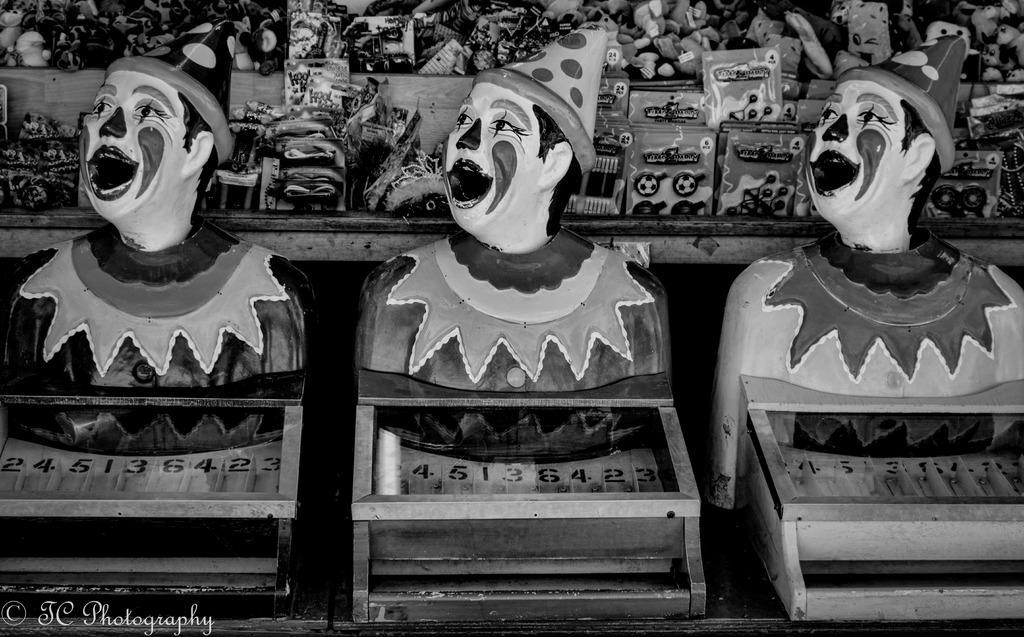How would you summarize this image in a sentence or two? In this image I can see the statues of the person. In the background I can see the toys and some objects. And this is a black and white image. 